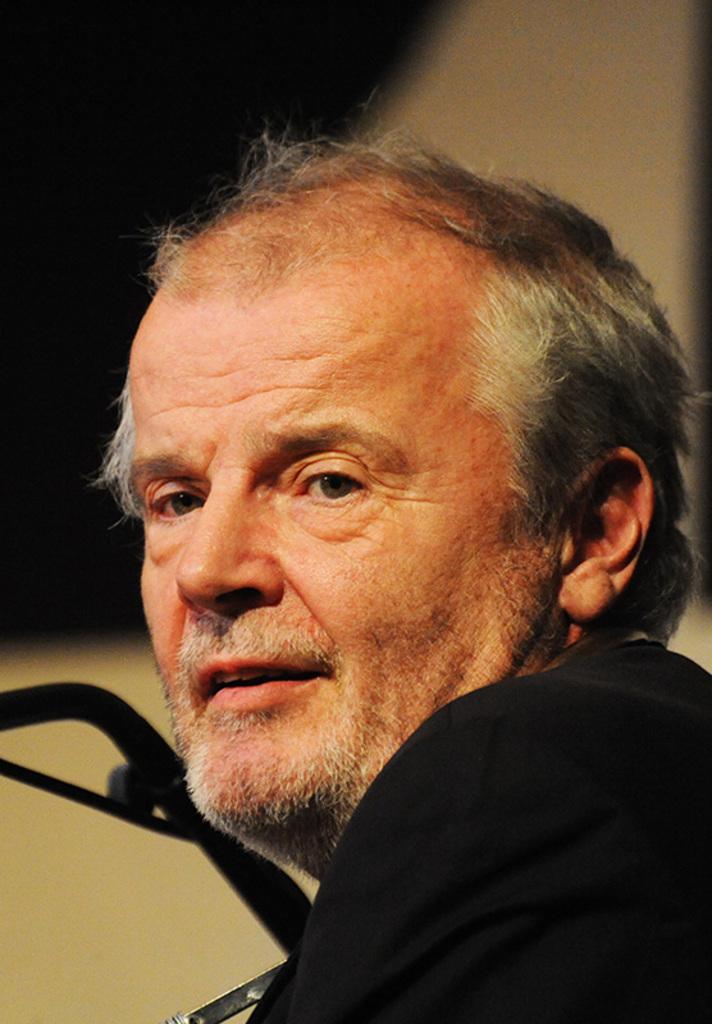Describe this image in one or two sentences. As we can see in the image in the front there is a man wearing black color jacket. In the background there is a wall and the background is little blurred. 